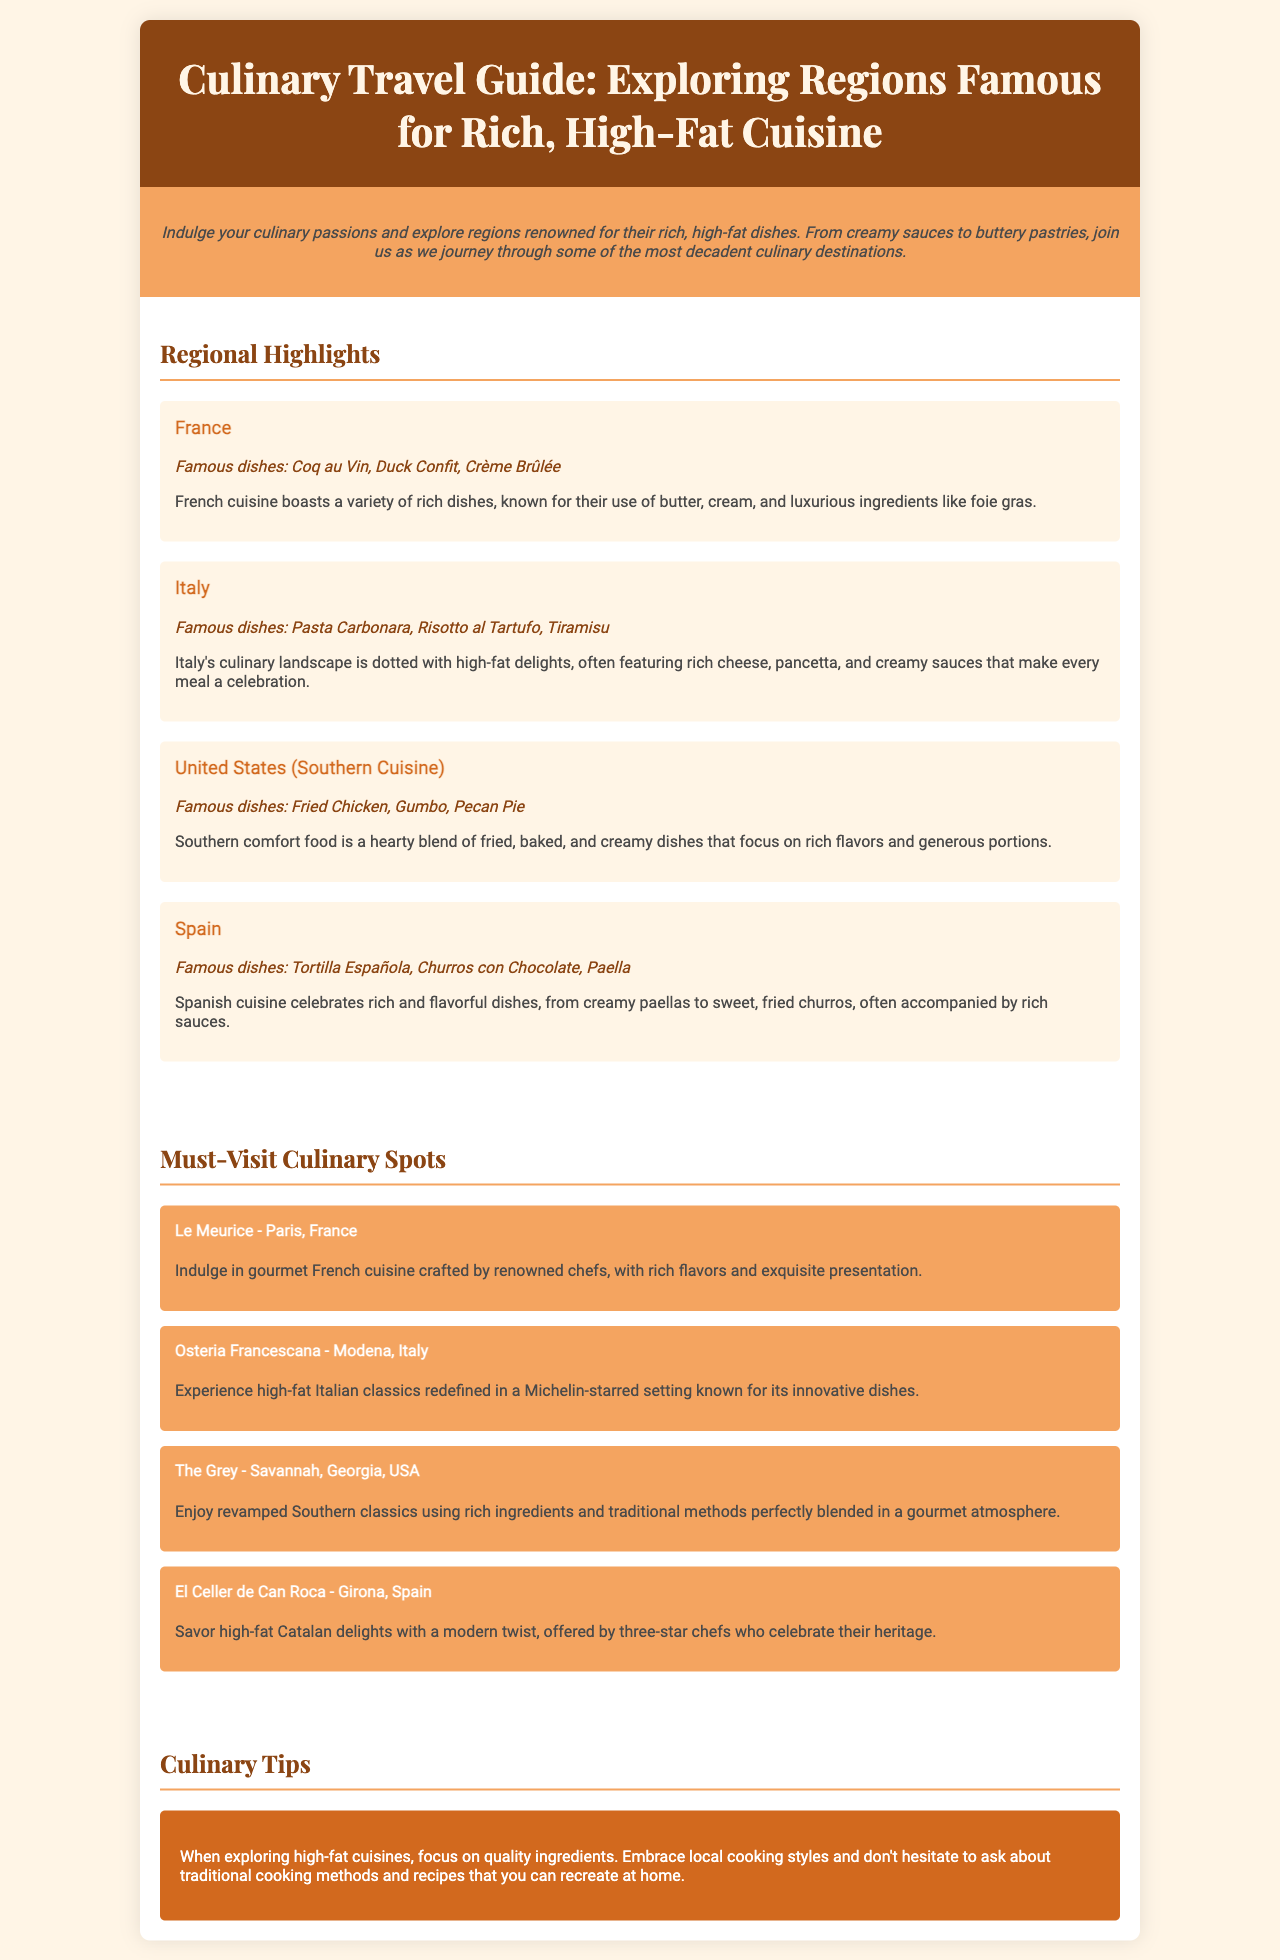What is the title of the brochure? The title is prominently displayed in the header of the document.
Answer: Culinary Travel Guide: Exploring Regions Famous for Rich, High-Fat Cuisine Which country is highlighted for Coq au Vin? The region section lists famous dishes along with their corresponding countries.
Answer: France What is a famous dish from Southern Cuisine? The document specifies notable dishes associated with each region.
Answer: Fried Chicken Name one culinary spot in Italy. The must-visit culinary spots section includes restaurants by region.
Answer: Osteria Francescana What is emphasized in the culinary tips section? The tips provide guidance specific to exploring high-fat cuisines.
Answer: Quality ingredients Which dish is mentioned under Spanish cuisine? The section outlines popular dishes from various regions.
Answer: Churros con Chocolate What cuisine uses butter and cream extensively? The description of French cuisine mentions the use of these ingredients.
Answer: French How many regions are highlighted in the document? The document lists a specific number of regional highlights.
Answer: Four 